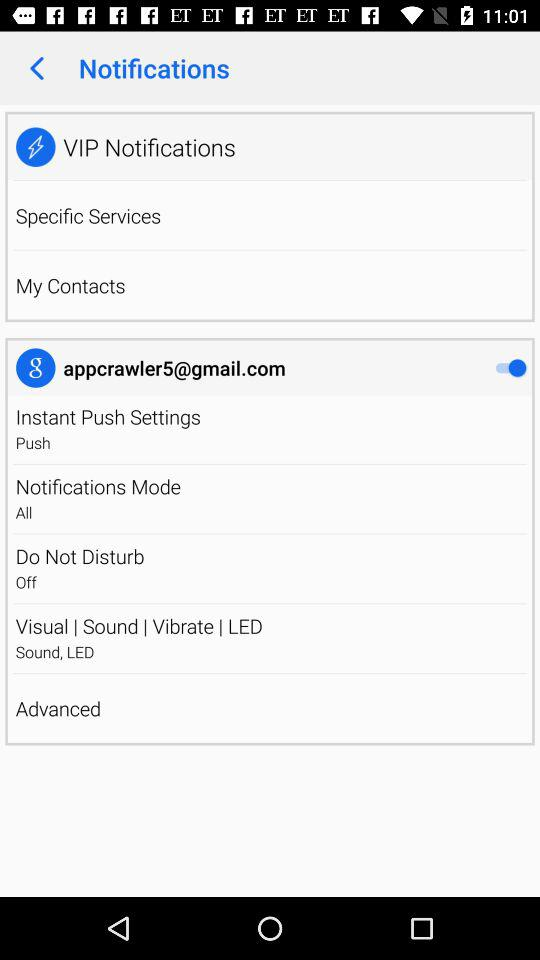What is the status of vibrate?
When the provided information is insufficient, respond with <no answer>. <no answer> 